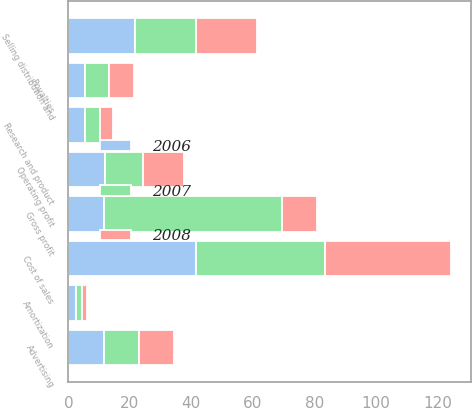Convert chart. <chart><loc_0><loc_0><loc_500><loc_500><stacked_bar_chart><ecel><fcel>Cost of sales<fcel>Gross profit<fcel>Amortization<fcel>Royalties<fcel>Research and product<fcel>Advertising<fcel>Selling distribution and<fcel>Operating profit<nl><fcel>2007<fcel>42.1<fcel>57.9<fcel>1.9<fcel>7.8<fcel>4.8<fcel>11.3<fcel>19.8<fcel>12.3<nl><fcel>2008<fcel>41.1<fcel>11.5<fcel>1.8<fcel>8.2<fcel>4.4<fcel>11.3<fcel>19.7<fcel>13.5<nl><fcel>2006<fcel>41.4<fcel>11.5<fcel>2.5<fcel>5.4<fcel>5.4<fcel>11.7<fcel>21.7<fcel>11.9<nl></chart> 